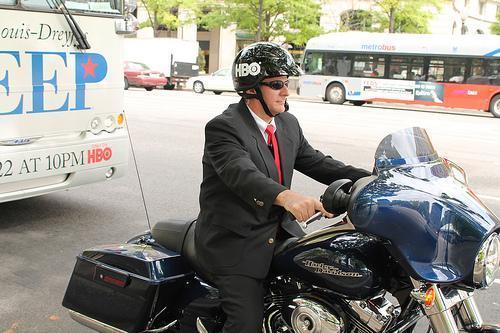How many buses are in this picture?
Give a very brief answer. 2. 